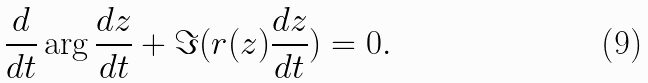Convert formula to latex. <formula><loc_0><loc_0><loc_500><loc_500>\frac { d } { d t } \arg \frac { d z } { d t } + \Im ( r ( z ) \frac { d z } { d t } ) = 0 .</formula> 